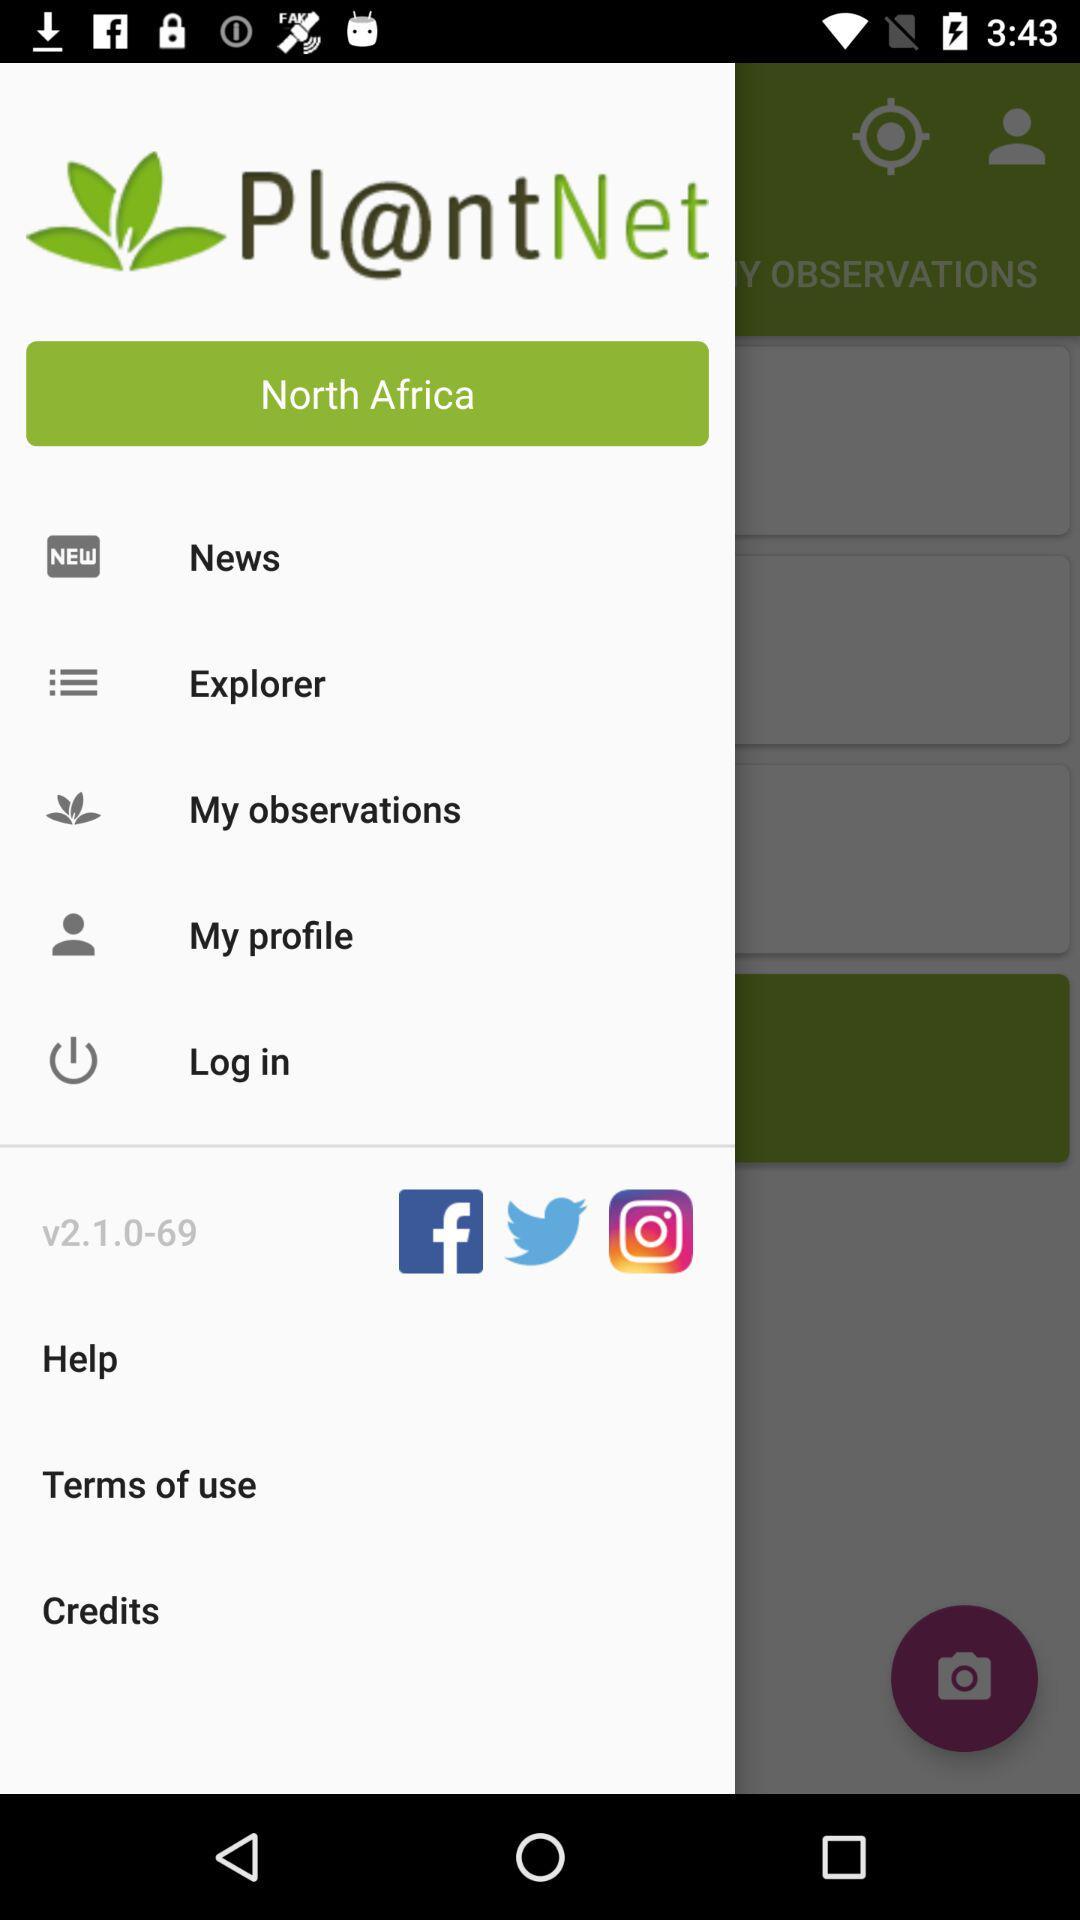What version of the application is this? The version of the application is v2.1.0-69. 